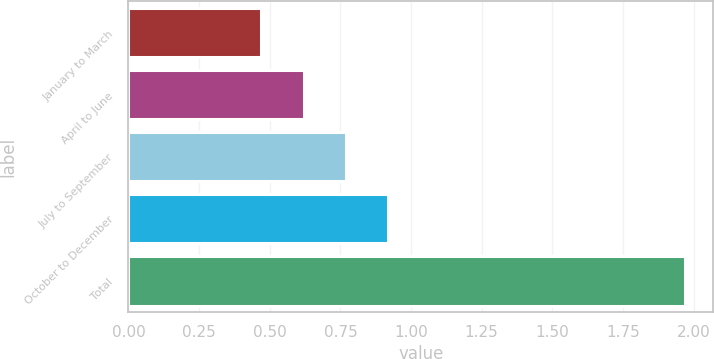Convert chart to OTSL. <chart><loc_0><loc_0><loc_500><loc_500><bar_chart><fcel>January to March<fcel>April to June<fcel>July to September<fcel>October to December<fcel>Total<nl><fcel>0.47<fcel>0.62<fcel>0.77<fcel>0.92<fcel>1.97<nl></chart> 